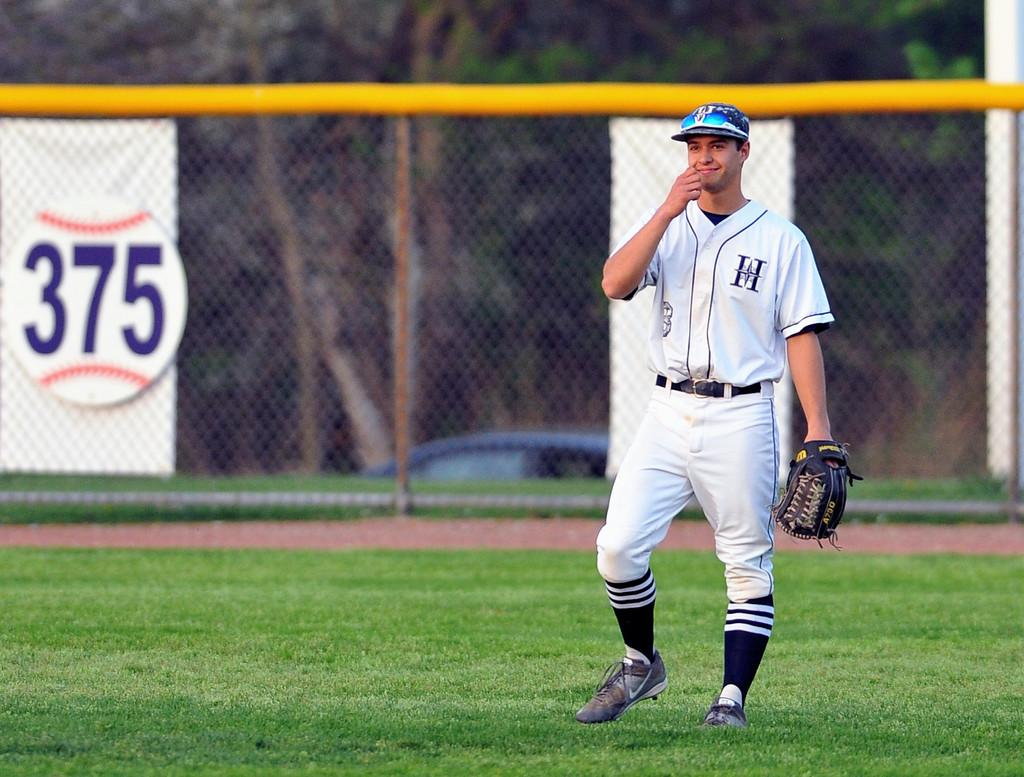<image>
Summarize the visual content of the image. A baseball catcher stands on a field in front of a round 375 sign. 